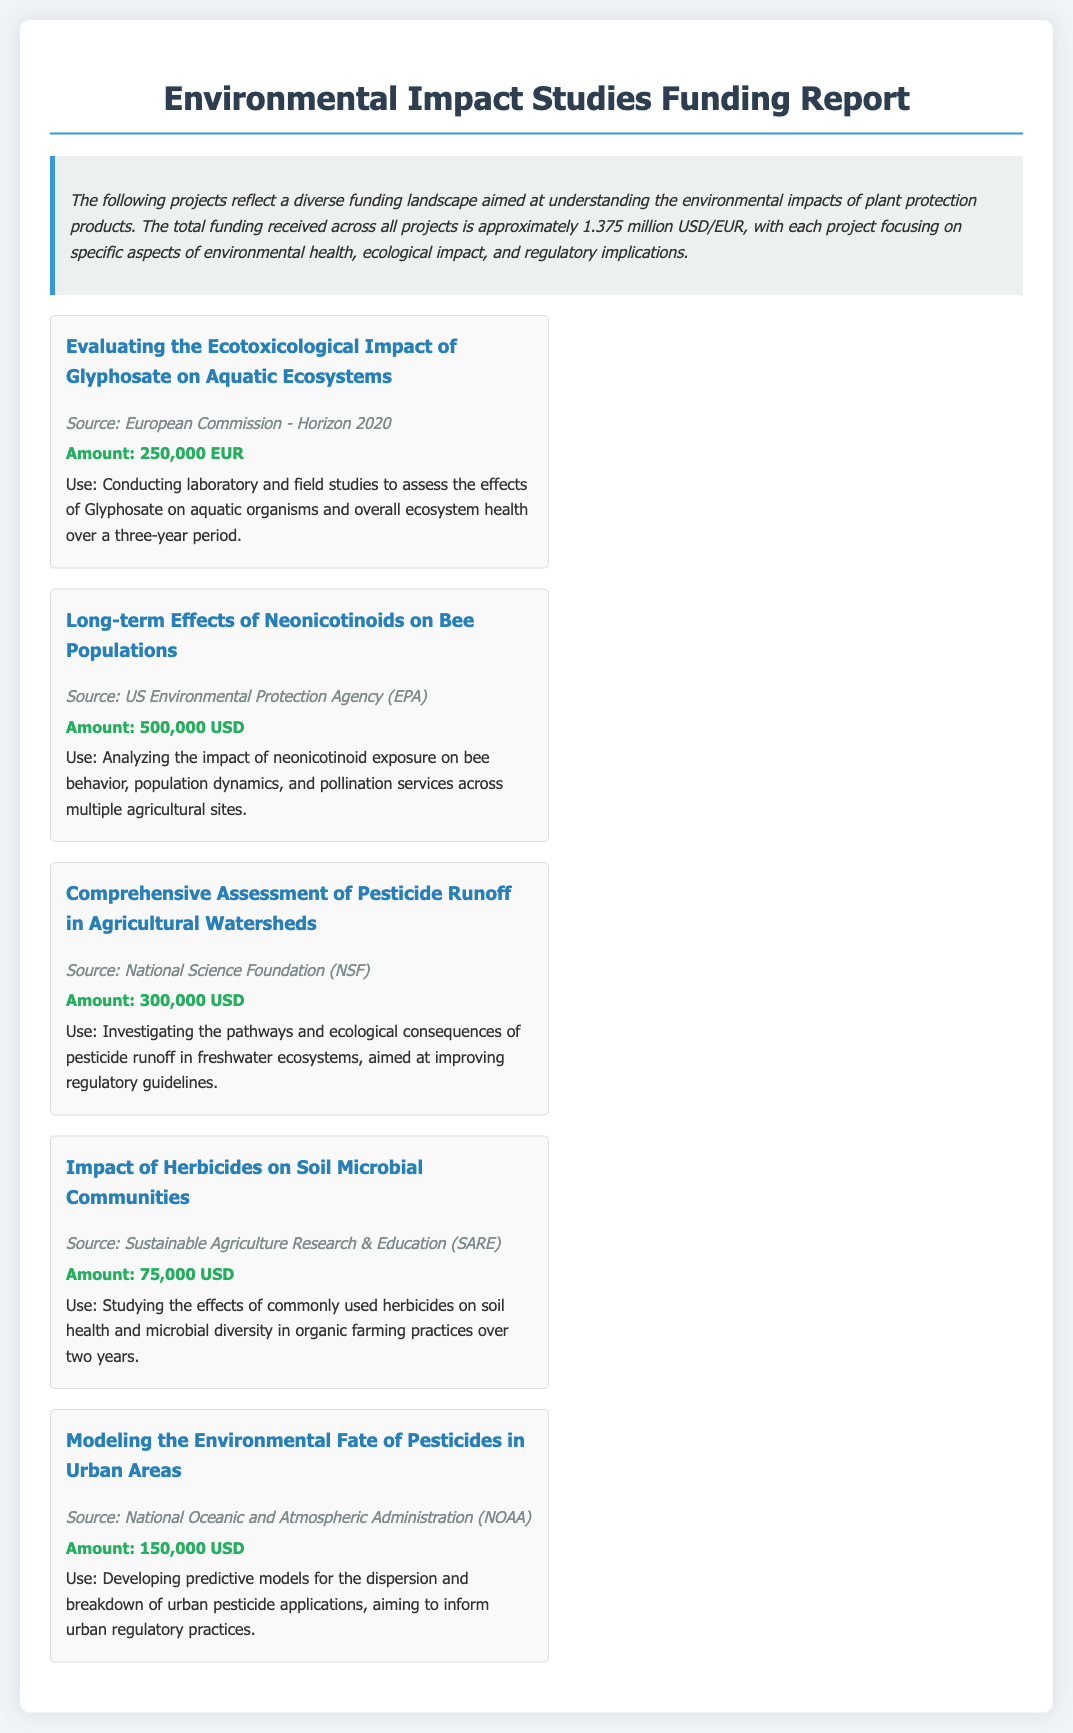What is the total funding received across all projects? The summary mentions that the total funding received across all projects is approximately 1.375 million USD/EUR.
Answer: 1.375 million USD/EUR Which source funded the project on the effects of neonicotinoids on bee populations? The document lists the source of funding for this project as the US Environmental Protection Agency (EPA).
Answer: US Environmental Protection Agency (EPA) How much funding was allocated for the project assessing Glyphosate's impact on aquatic ecosystems? The amount for this project, as stated in the document, is 250,000 EUR.
Answer: 250,000 EUR What is the primary focus of the project funded by the National Science Foundation (NSF)? The document outlines that this project investigates the pathways and ecological consequences of pesticide runoff in freshwater ecosystems.
Answer: Pesticide runoff in freshwater ecosystems What is the intended use of the funds received for the project modeling pesticide fate in urban areas? The funds are intended for developing predictive models for the dispersion and breakdown of urban pesticide applications.
Answer: Developing predictive models How much funding is dedicated to studying the impact of herbicides on soil microbial communities? The document specifies that the funding amount for this study is 75,000 USD.
Answer: 75,000 USD Which project has the highest funding amount? By comparing the funding amounts, the project on Long-term Effects of Neonicotinoids on Bee Populations has the highest funding of 500,000 USD.
Answer: Long-term Effects of Neonicotinoids on Bee Populations What is the duration of the studies on Glyphosate's effects mentioned in the report? The project states the studies are to be conducted over a three-year period.
Answer: Three years 